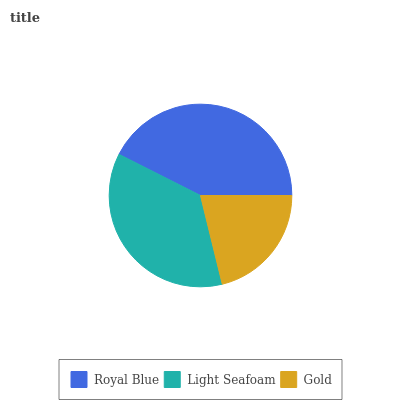Is Gold the minimum?
Answer yes or no. Yes. Is Royal Blue the maximum?
Answer yes or no. Yes. Is Light Seafoam the minimum?
Answer yes or no. No. Is Light Seafoam the maximum?
Answer yes or no. No. Is Royal Blue greater than Light Seafoam?
Answer yes or no. Yes. Is Light Seafoam less than Royal Blue?
Answer yes or no. Yes. Is Light Seafoam greater than Royal Blue?
Answer yes or no. No. Is Royal Blue less than Light Seafoam?
Answer yes or no. No. Is Light Seafoam the high median?
Answer yes or no. Yes. Is Light Seafoam the low median?
Answer yes or no. Yes. Is Gold the high median?
Answer yes or no. No. Is Royal Blue the low median?
Answer yes or no. No. 